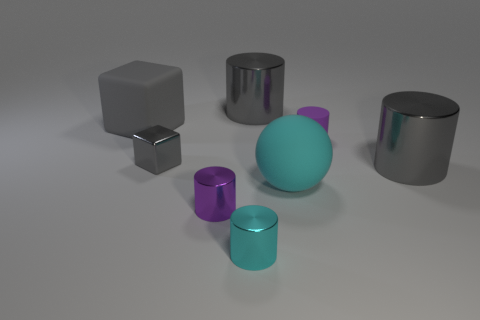Are there any indications about the lighting in the scene? The lighting in the scene seems uniform with a soft shadowing effect under each object, indicating a diffuse light source above, likely simulating an overcast sky or soft-box lighting commonly used in studio photography to avoid harsh shadows. 